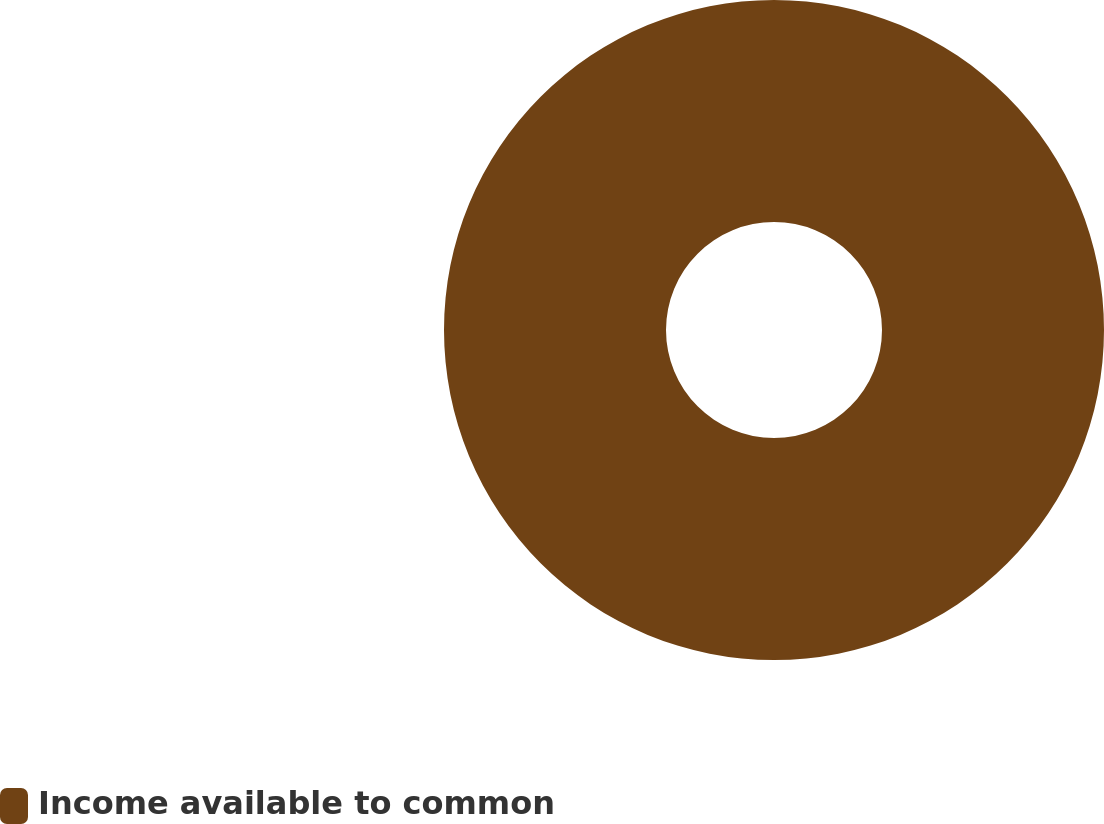<chart> <loc_0><loc_0><loc_500><loc_500><pie_chart><fcel>Income available to common<nl><fcel>100.0%<nl></chart> 